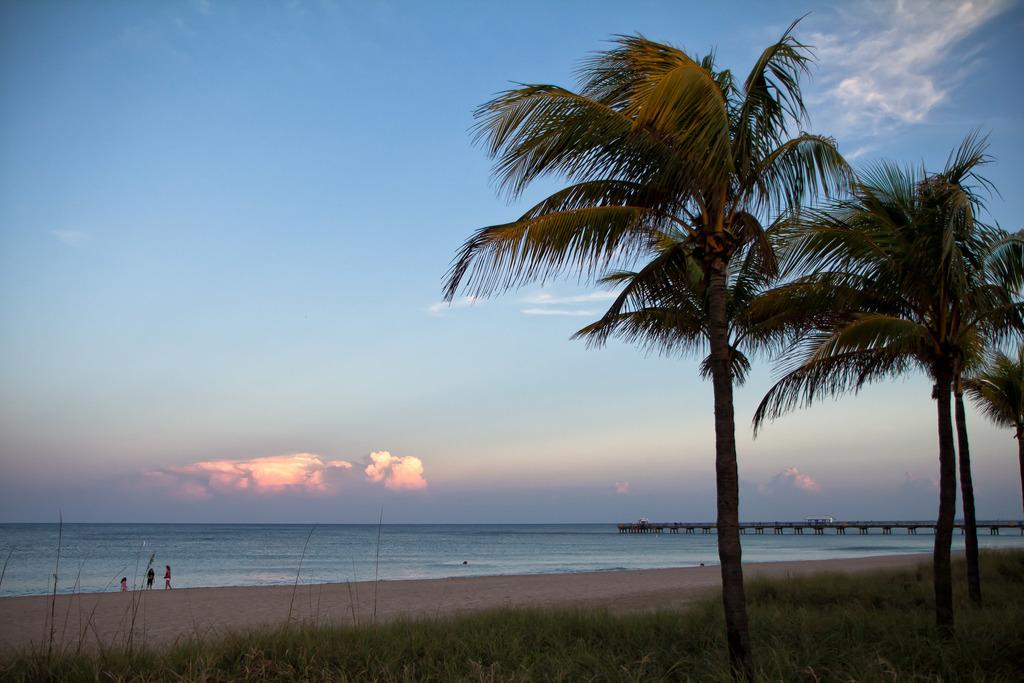What type of natural environment is depicted in the image? The image contains grass, trees, a beach, and water, indicating a natural environment. What can be seen in the sky in the image? There are clouds visible in the sky in the image. Can the sky be seen in the image? Yes, the sky is visible in the image. Are there any people present in the image? Yes, there are people in the image. What type of chair is being used by the people to show respect in the image? There is no chair or indication of respect present in the image. 